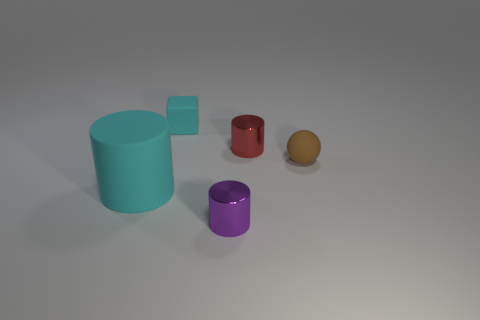Is there any other thing that has the same size as the rubber cylinder?
Your answer should be very brief. No. Is the material of the small cylinder in front of the tiny red metal thing the same as the small cylinder that is behind the large matte object?
Your answer should be very brief. Yes. The red object that is the same size as the cyan block is what shape?
Keep it short and to the point. Cylinder. What number of other objects are the same color as the small rubber cube?
Provide a short and direct response. 1. What is the color of the tiny cylinder that is in front of the ball?
Give a very brief answer. Purple. How many other things are the same material as the red cylinder?
Offer a terse response. 1. Are there more cylinders right of the small purple metallic object than cylinders that are to the left of the cyan rubber cylinder?
Provide a short and direct response. Yes. There is a small cyan rubber cube; how many tiny cylinders are in front of it?
Provide a succinct answer. 2. Is the tiny brown object made of the same material as the tiny thing on the left side of the tiny purple thing?
Your answer should be compact. Yes. Is there anything else that has the same shape as the tiny brown object?
Keep it short and to the point. No. 